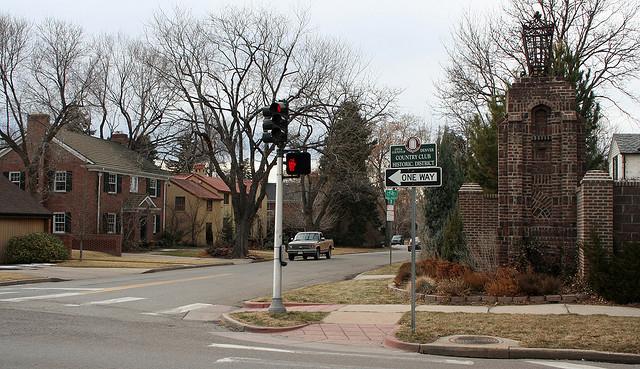Which way is the arrow pointing?
Give a very brief answer. Left. Are there any people on the street?
Be succinct. No. Can a pedestrian go forward now?
Quick response, please. No. Why are the trees barren?
Answer briefly. Winter. 